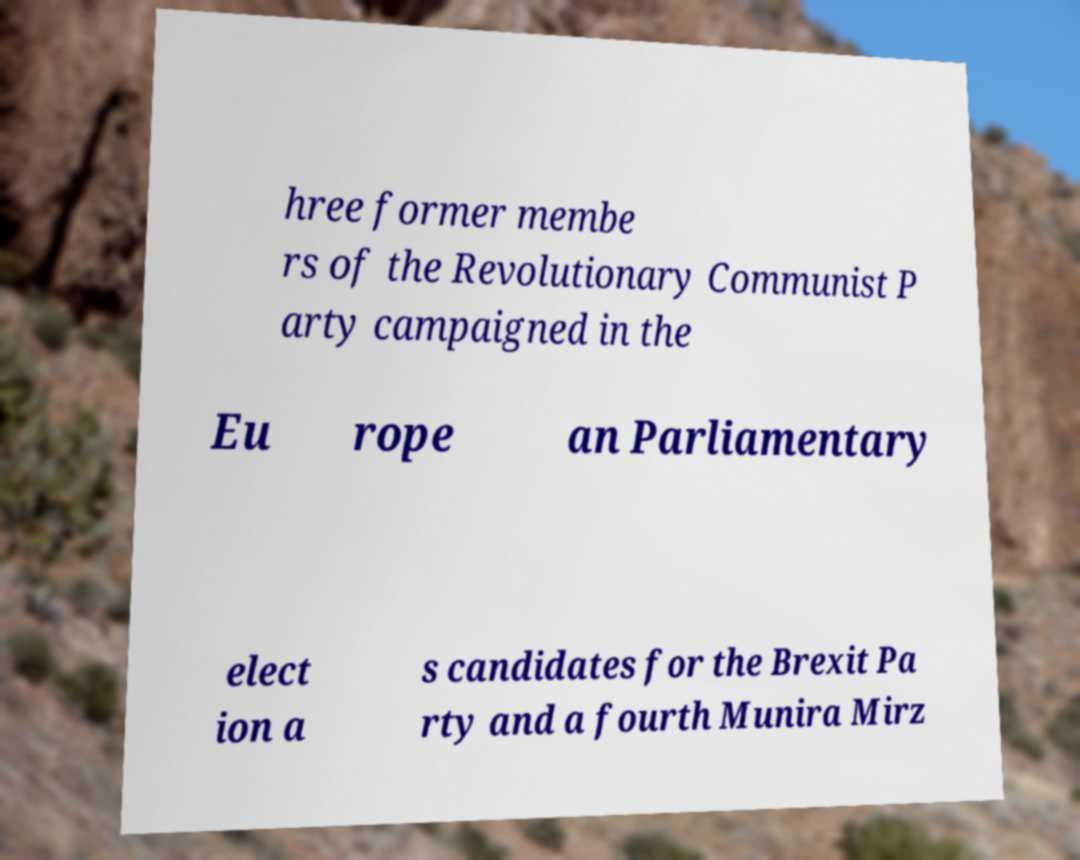There's text embedded in this image that I need extracted. Can you transcribe it verbatim? hree former membe rs of the Revolutionary Communist P arty campaigned in the Eu rope an Parliamentary elect ion a s candidates for the Brexit Pa rty and a fourth Munira Mirz 